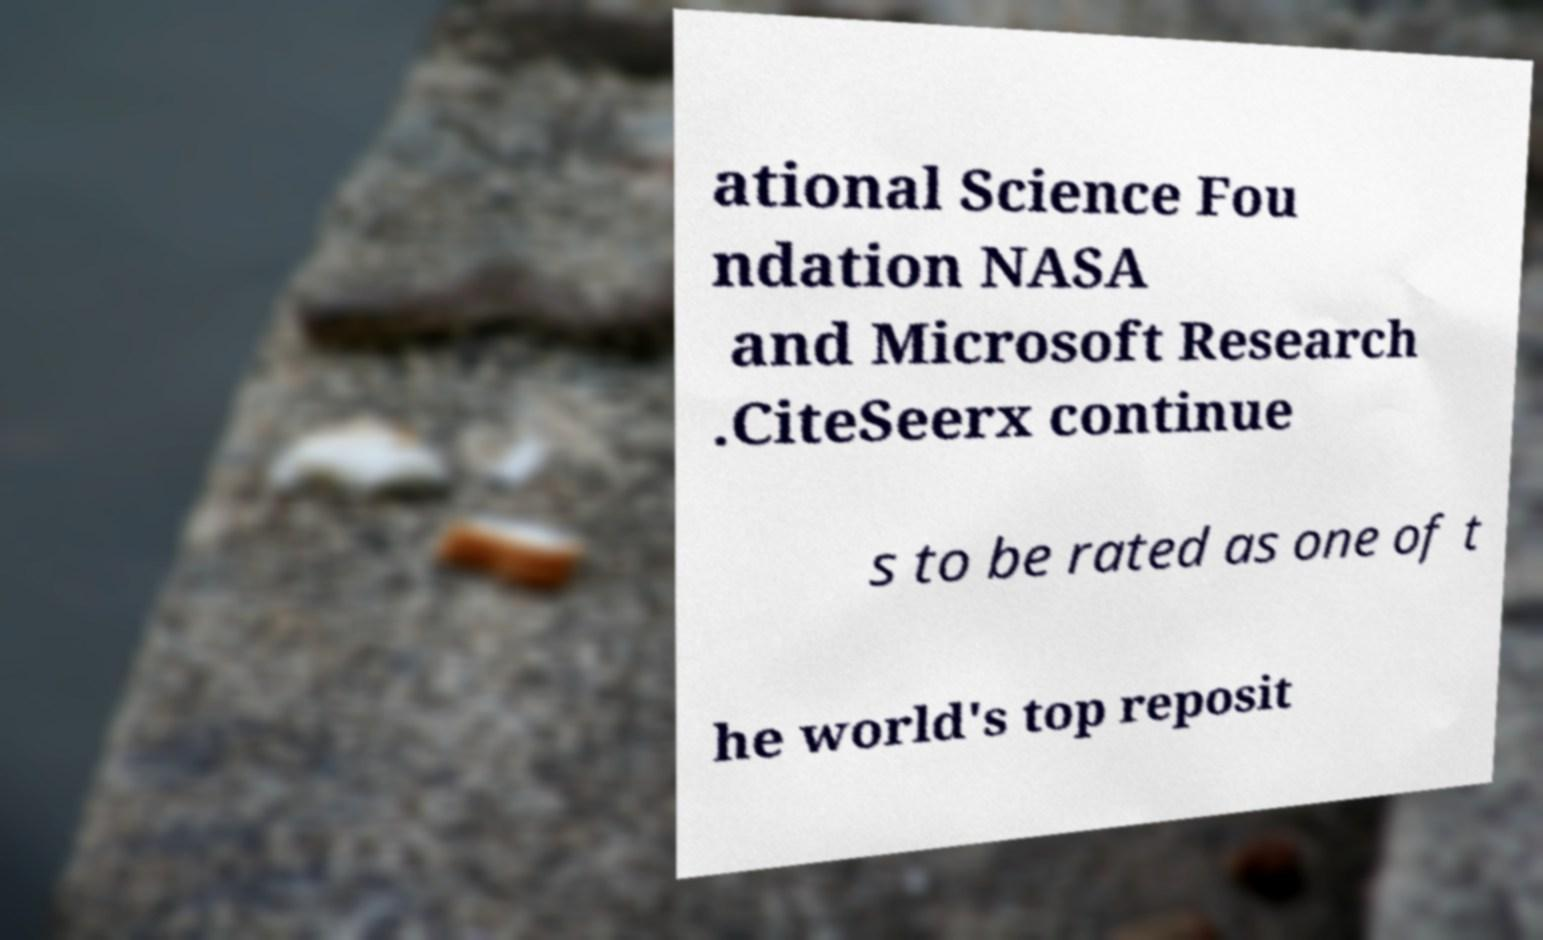I need the written content from this picture converted into text. Can you do that? ational Science Fou ndation NASA and Microsoft Research .CiteSeerx continue s to be rated as one of t he world's top reposit 